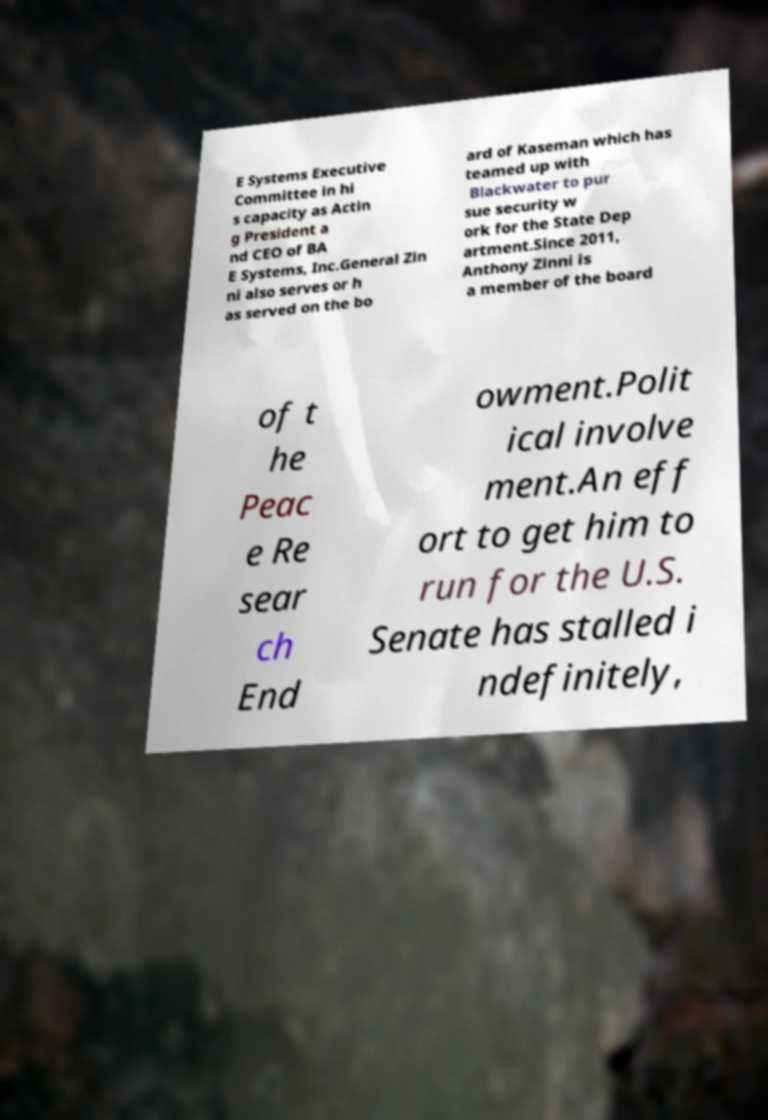I need the written content from this picture converted into text. Can you do that? E Systems Executive Committee in hi s capacity as Actin g President a nd CEO of BA E Systems, Inc.General Zin ni also serves or h as served on the bo ard of Kaseman which has teamed up with Blackwater to pur sue security w ork for the State Dep artment.Since 2011, Anthony Zinni is a member of the board of t he Peac e Re sear ch End owment.Polit ical involve ment.An eff ort to get him to run for the U.S. Senate has stalled i ndefinitely, 